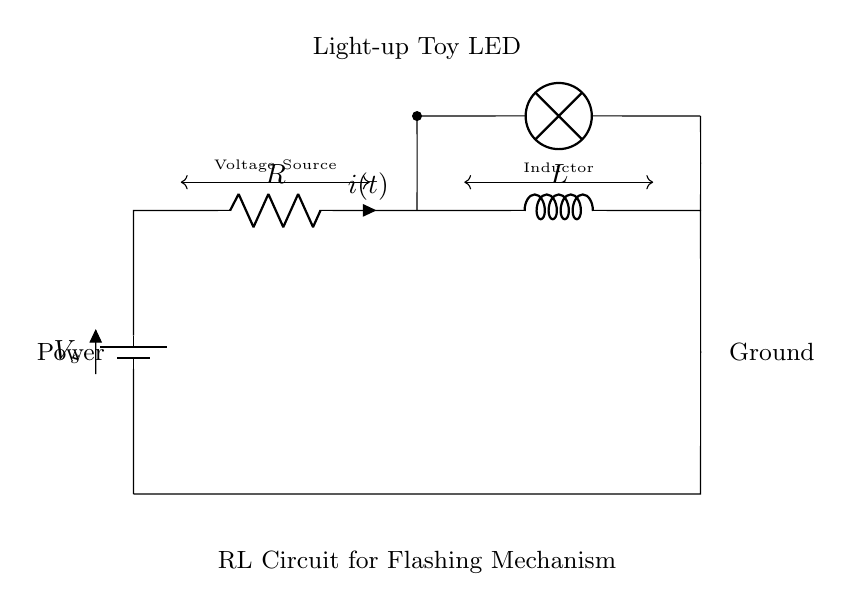What are the components in this circuit? The circuit contains a voltage source (battery), a resistor, an inductor, and a lamp (LED). These components can be identified in the diagram, with labels next to them indicating their functions.
Answer: voltage source, resistor, inductor, lamp What is the function of the inductor in this circuit? The inductor in this circuit serves to store energy in a magnetic field when current flows through it. It helps in controlling the rate of current change, contributing to the varied brightness patterns of the LED by allowing it to flash.
Answer: energy storage What does the lamp represent in the circuit? The lamp in the diagram represents the light-up toy's LED that lights up when current passes through the circuit. The LED's brightness patterns depend on the properties of the RL circuit, specifically how quickly the current changes.
Answer: light-up toy LED How does the flash mechanism work in this circuit? The flash mechanism works due to the combination of resistor and inductor which controls the current flow. When current is initially applied, it gradually increases through the inductor, causing the LED to light up at varying levels. The resistance affects how quickly this happens, influencing the flash patterns.
Answer: resistor and inductor control What is the current direction in the circuit? The current flows from the positive terminal of the battery through the resistor, then through the inductor, and back to the negative terminal of the battery. This directional flow is indicated by the current arrow labeled in the circuit.
Answer: from battery positive to negative What happens to the LED when the inductor discharges? When the inductor discharges, it releases the energy stored in its magnetic field back into the circuit. This results in a sudden increase in current, causing the LED to brighten and potentially flash briefly before settling to a lower brightness level, depending on the circuit dynamics.
Answer: LED brightens briefly How does resistance affect the LED brightness? The resistance affects the current flow in the circuit. A higher resistance reduces the current, leading to dimmer LED brightness, while lower resistance allows more current to flow, resulting in a brighter LED.
Answer: higher resistance = dimmer LED 